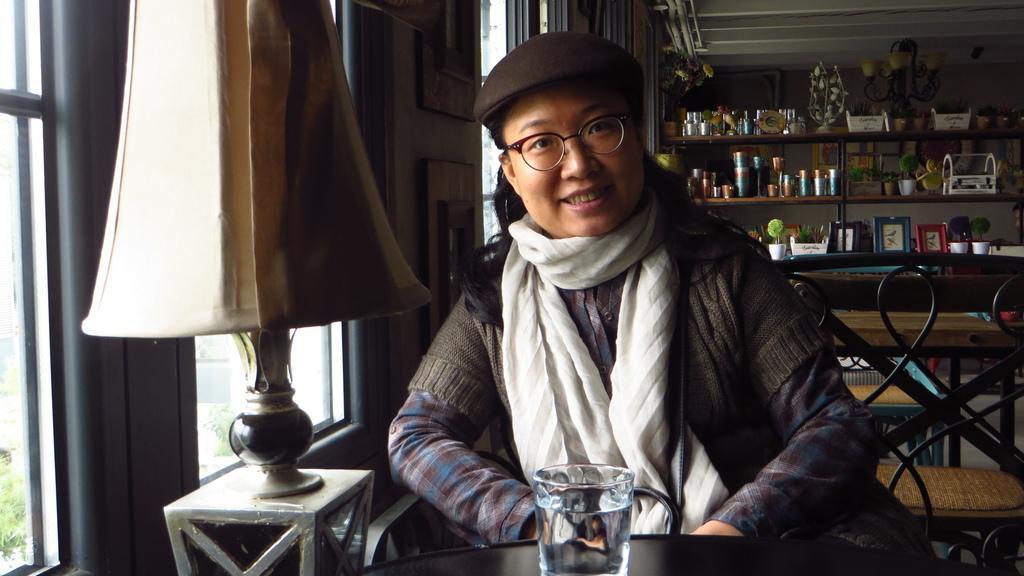Can you describe this image briefly? In this picture I can see a human setting a glass on the table and I can see few items on the shelves in the back and I can see couple of chairs and a table, I can see a lamp on the left side and few glass windows from the glass I can see trees and another building. 